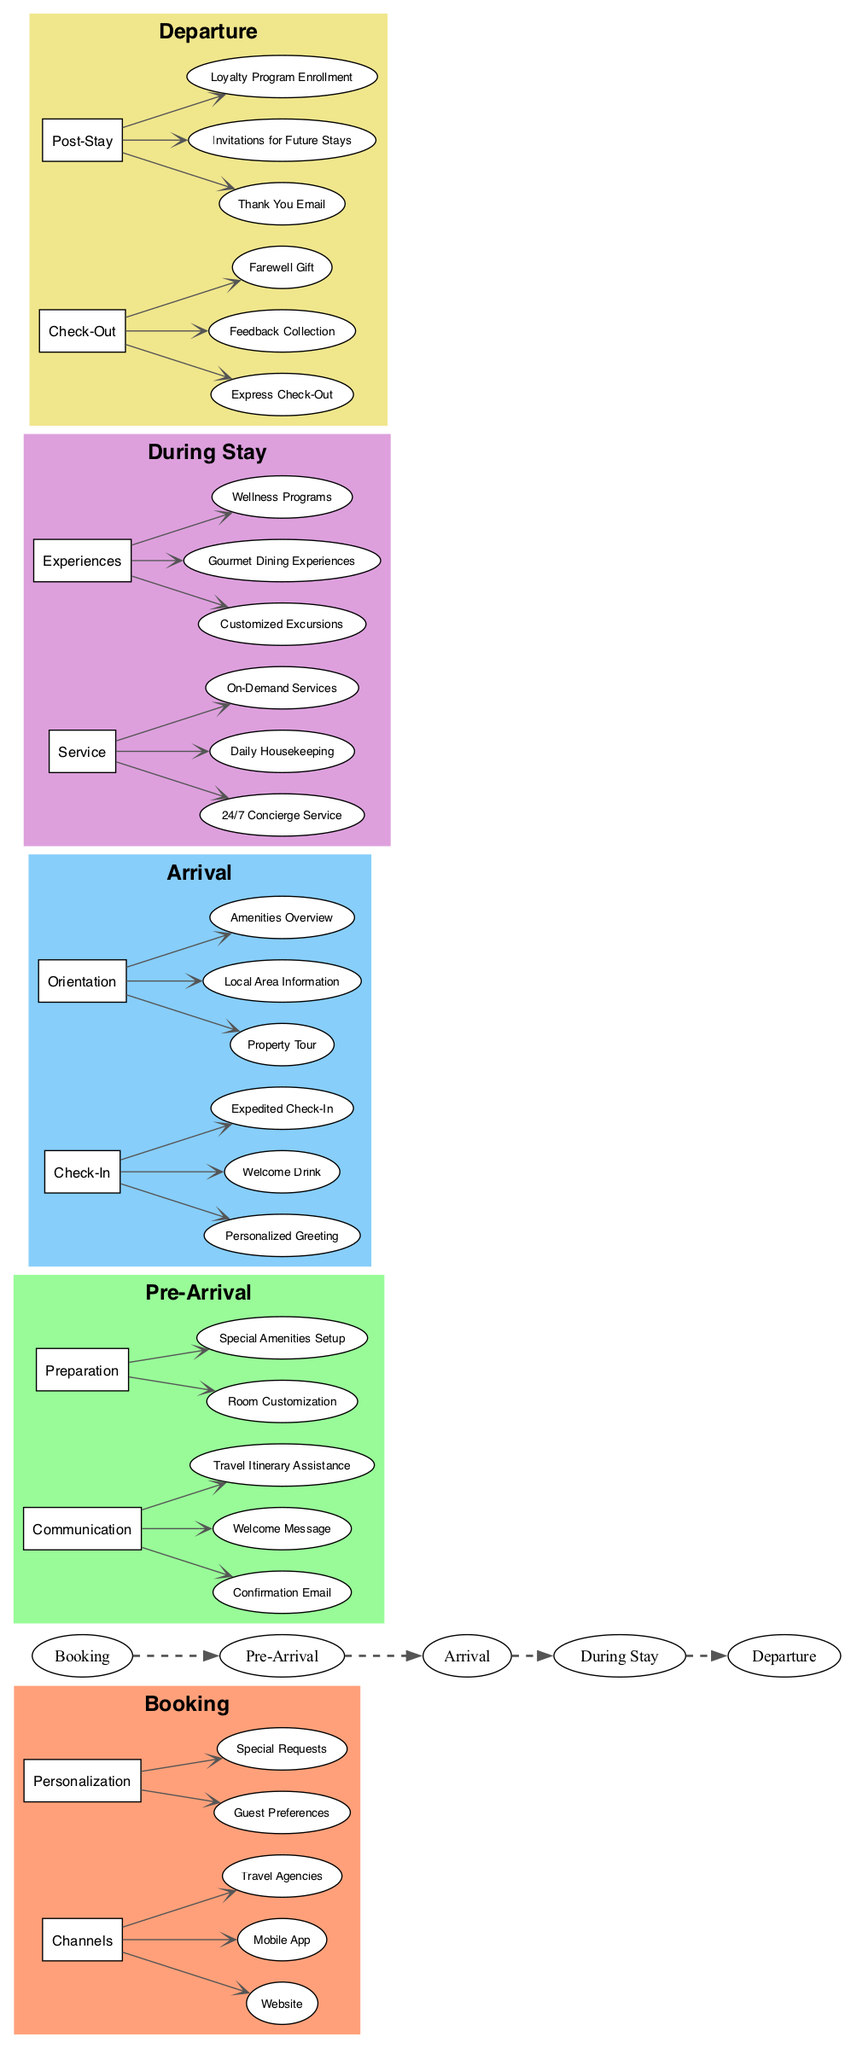What are the channels for booking? The diagram shows three channels listed under the "Booking" stage: Website, Mobile App, and Travel Agencies.
Answer: Website, Mobile App, Travel Agencies What is included in pre-arrival communication? The diagram lists three elements under the "Pre-Arrival" stage for communication: Confirmation Email, Welcome Message, and Travel Itinerary Assistance.
Answer: Confirmation Email, Welcome Message, Travel Itinerary Assistance How many experiences are offered during the stay? Under the "During Stay" stage, there are three experiences listed: Customized Excursions, Gourmet Dining Experiences, and Wellness Programs. Therefore, the total number of experiences is three.
Answer: 3 What facilitates the guest's arrival? The "Arrival" stage includes Check-In and Orientation; specifically, it lists Personalized Greeting, Welcome Drink, and Expedited Check-In under Check-In, and Property Tour, Local Area Information, and Amenities Overview under Orientation. This indicates that both Check-In and Orientation play a key role in facilitating the guest's arrival.
Answer: Check-In and Orientation What is the relationship between feedback collection and check-out? The diagram shows that feedback collection is listed as part of the check-out process under the "Departure" stage, indicating that guests are prompted to provide feedback during their check-out.
Answer: Feedback collection is part of check-out Which stage includes loyalty program enrollment? Loyalty program enrollment is listed under the "Post-Stay" section of the "Departure" stage in the diagram. This indicates that the loyalty program is addressed after guests have departed.
Answer: Post-Stay How is the guest’s experience personalized in the booking stage? The diagram indicates that the personalization during the booking stage includes guest preferences and special requests, meaning these factors are taken into account to tailor the booking experience.
Answer: Guest Preferences and Special Requests What type of service is available 24/7 during the stay? According to the "During Stay" section of the diagram, 24/7 Concierge Service is listed as a type of service available to guests at any time.
Answer: 24/7 Concierge Service 